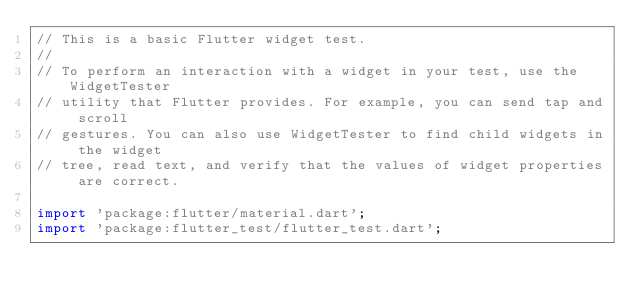Convert code to text. <code><loc_0><loc_0><loc_500><loc_500><_Dart_>// This is a basic Flutter widget test.
//
// To perform an interaction with a widget in your test, use the WidgetTester
// utility that Flutter provides. For example, you can send tap and scroll
// gestures. You can also use WidgetTester to find child widgets in the widget
// tree, read text, and verify that the values of widget properties are correct.

import 'package:flutter/material.dart';
import 'package:flutter_test/flutter_test.dart';
</code> 